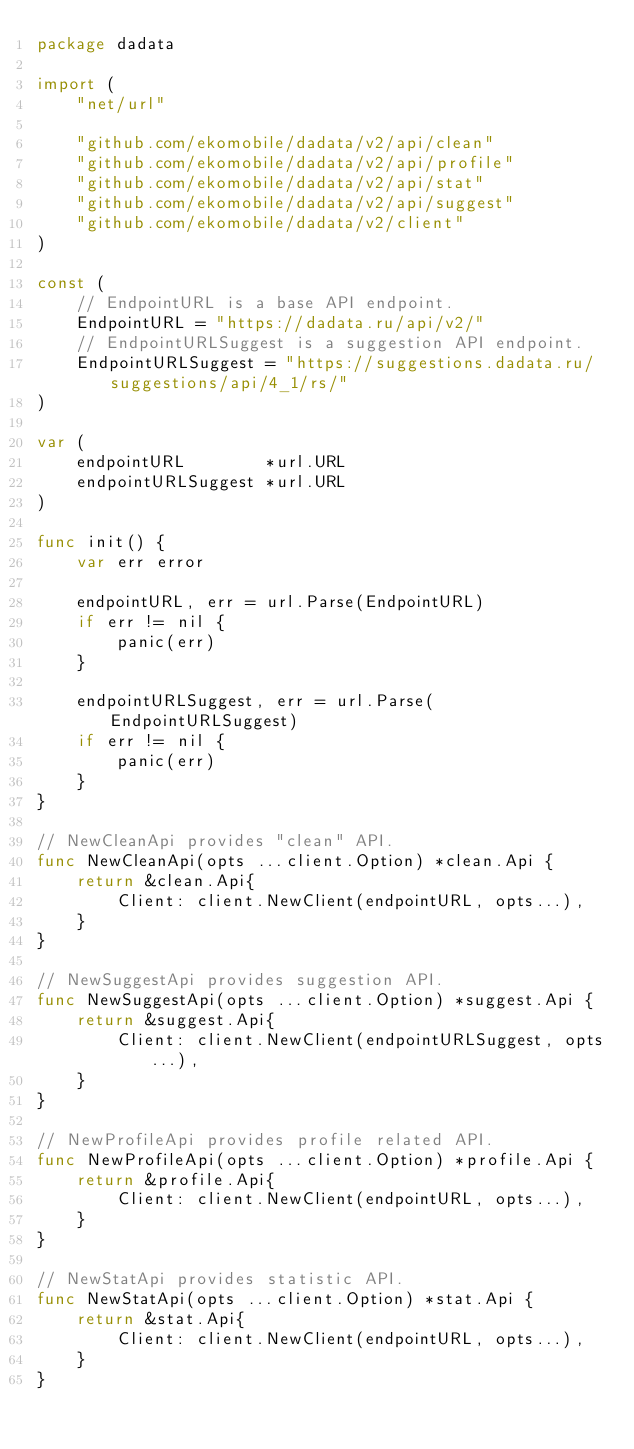<code> <loc_0><loc_0><loc_500><loc_500><_Go_>package dadata

import (
	"net/url"

	"github.com/ekomobile/dadata/v2/api/clean"
	"github.com/ekomobile/dadata/v2/api/profile"
	"github.com/ekomobile/dadata/v2/api/stat"
	"github.com/ekomobile/dadata/v2/api/suggest"
	"github.com/ekomobile/dadata/v2/client"
)

const (
	// EndpointURL is a base API endpoint.
	EndpointURL = "https://dadata.ru/api/v2/"
	// EndpointURLSuggest is a suggestion API endpoint.
	EndpointURLSuggest = "https://suggestions.dadata.ru/suggestions/api/4_1/rs/"
)

var (
	endpointURL        *url.URL
	endpointURLSuggest *url.URL
)

func init() {
	var err error

	endpointURL, err = url.Parse(EndpointURL)
	if err != nil {
		panic(err)
	}

	endpointURLSuggest, err = url.Parse(EndpointURLSuggest)
	if err != nil {
		panic(err)
	}
}

// NewCleanApi provides "clean" API.
func NewCleanApi(opts ...client.Option) *clean.Api {
	return &clean.Api{
		Client: client.NewClient(endpointURL, opts...),
	}
}

// NewSuggestApi provides suggestion API.
func NewSuggestApi(opts ...client.Option) *suggest.Api {
	return &suggest.Api{
		Client: client.NewClient(endpointURLSuggest, opts...),
	}
}

// NewProfileApi provides profile related API.
func NewProfileApi(opts ...client.Option) *profile.Api {
	return &profile.Api{
		Client: client.NewClient(endpointURL, opts...),
	}
}

// NewStatApi provides statistic API.
func NewStatApi(opts ...client.Option) *stat.Api {
	return &stat.Api{
		Client: client.NewClient(endpointURL, opts...),
	}
}
</code> 